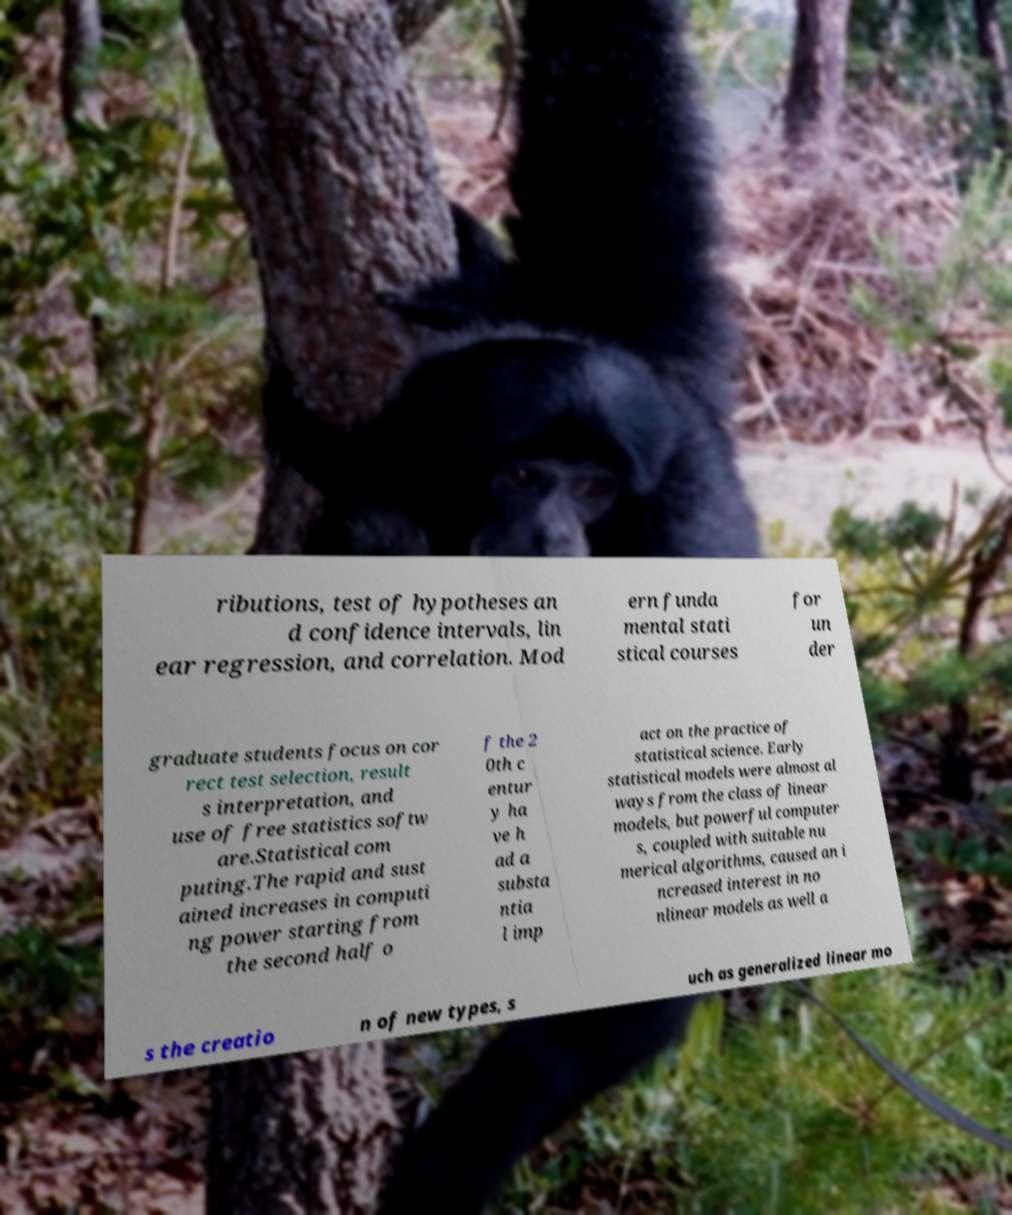Can you read and provide the text displayed in the image?This photo seems to have some interesting text. Can you extract and type it out for me? ributions, test of hypotheses an d confidence intervals, lin ear regression, and correlation. Mod ern funda mental stati stical courses for un der graduate students focus on cor rect test selection, result s interpretation, and use of free statistics softw are.Statistical com puting.The rapid and sust ained increases in computi ng power starting from the second half o f the 2 0th c entur y ha ve h ad a substa ntia l imp act on the practice of statistical science. Early statistical models were almost al ways from the class of linear models, but powerful computer s, coupled with suitable nu merical algorithms, caused an i ncreased interest in no nlinear models as well a s the creatio n of new types, s uch as generalized linear mo 